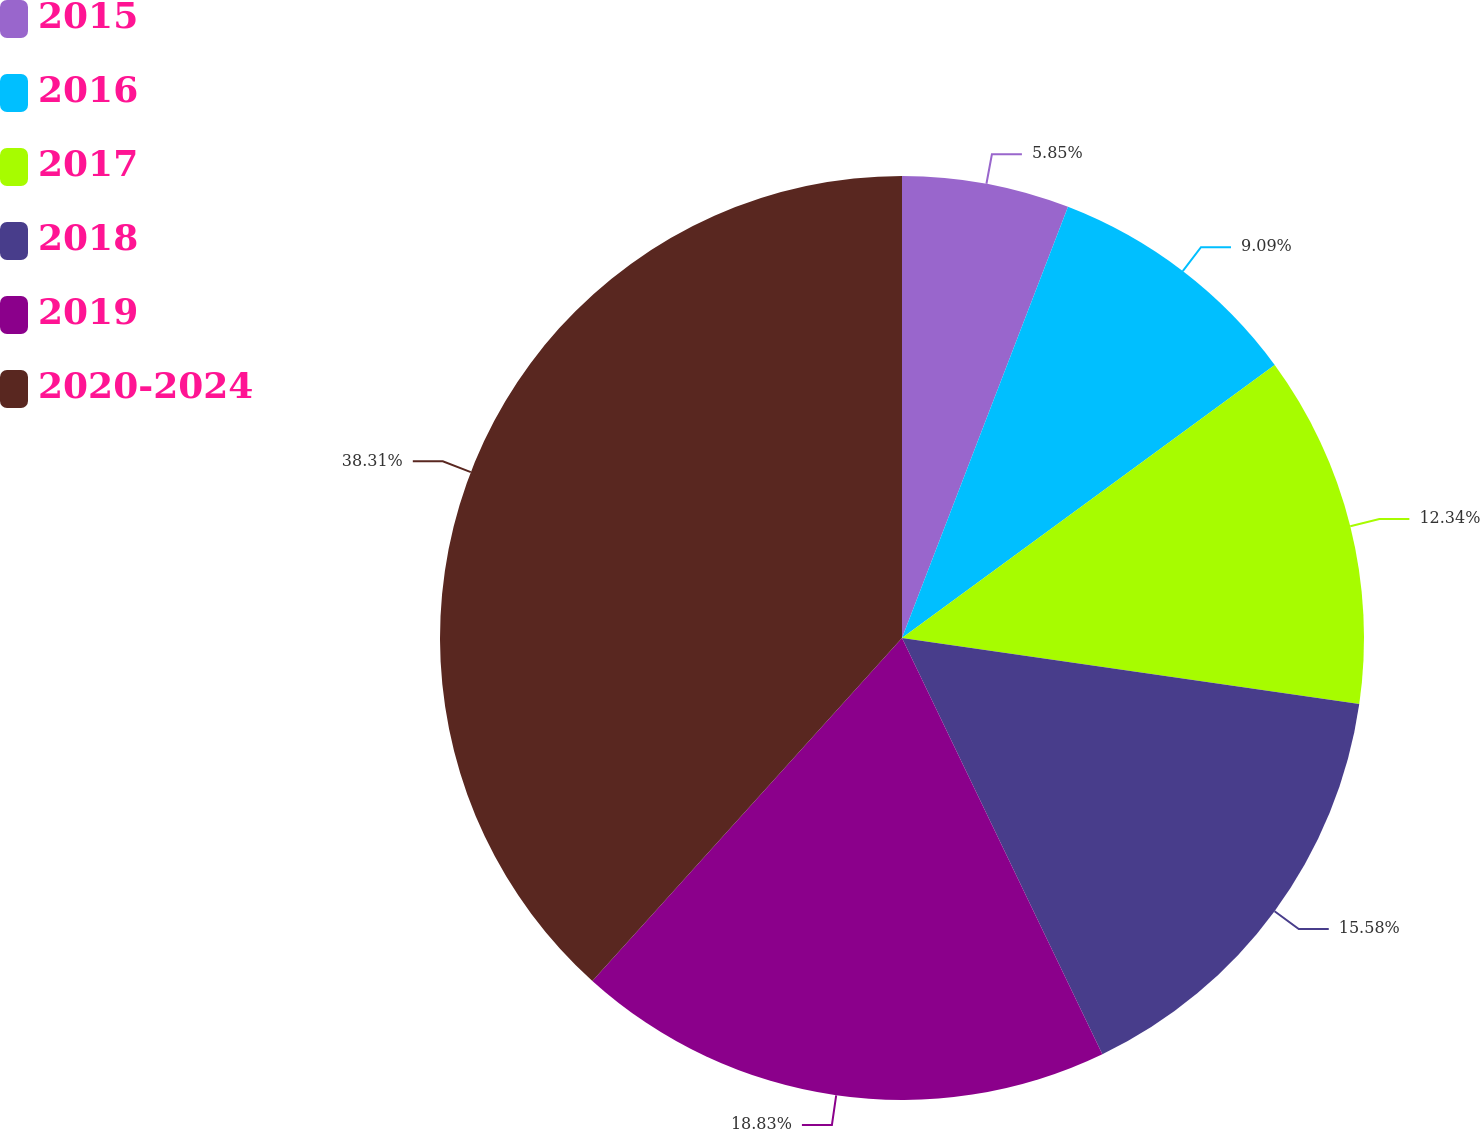<chart> <loc_0><loc_0><loc_500><loc_500><pie_chart><fcel>2015<fcel>2016<fcel>2017<fcel>2018<fcel>2019<fcel>2020-2024<nl><fcel>5.85%<fcel>9.09%<fcel>12.34%<fcel>15.58%<fcel>18.83%<fcel>38.31%<nl></chart> 